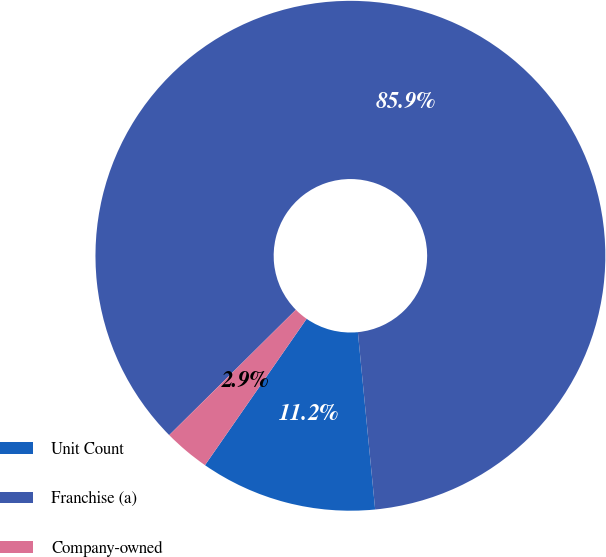Convert chart to OTSL. <chart><loc_0><loc_0><loc_500><loc_500><pie_chart><fcel>Unit Count<fcel>Franchise (a)<fcel>Company-owned<nl><fcel>11.21%<fcel>85.87%<fcel>2.92%<nl></chart> 